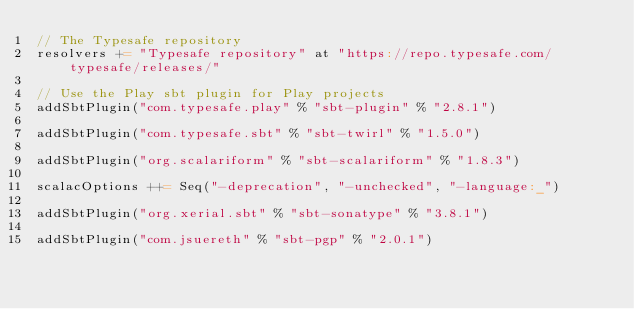Convert code to text. <code><loc_0><loc_0><loc_500><loc_500><_Scala_>// The Typesafe repository
resolvers += "Typesafe repository" at "https://repo.typesafe.com/typesafe/releases/"

// Use the Play sbt plugin for Play projects
addSbtPlugin("com.typesafe.play" % "sbt-plugin" % "2.8.1")

addSbtPlugin("com.typesafe.sbt" % "sbt-twirl" % "1.5.0")

addSbtPlugin("org.scalariform" % "sbt-scalariform" % "1.8.3")

scalacOptions ++= Seq("-deprecation", "-unchecked", "-language:_")

addSbtPlugin("org.xerial.sbt" % "sbt-sonatype" % "3.8.1")

addSbtPlugin("com.jsuereth" % "sbt-pgp" % "2.0.1")
</code> 